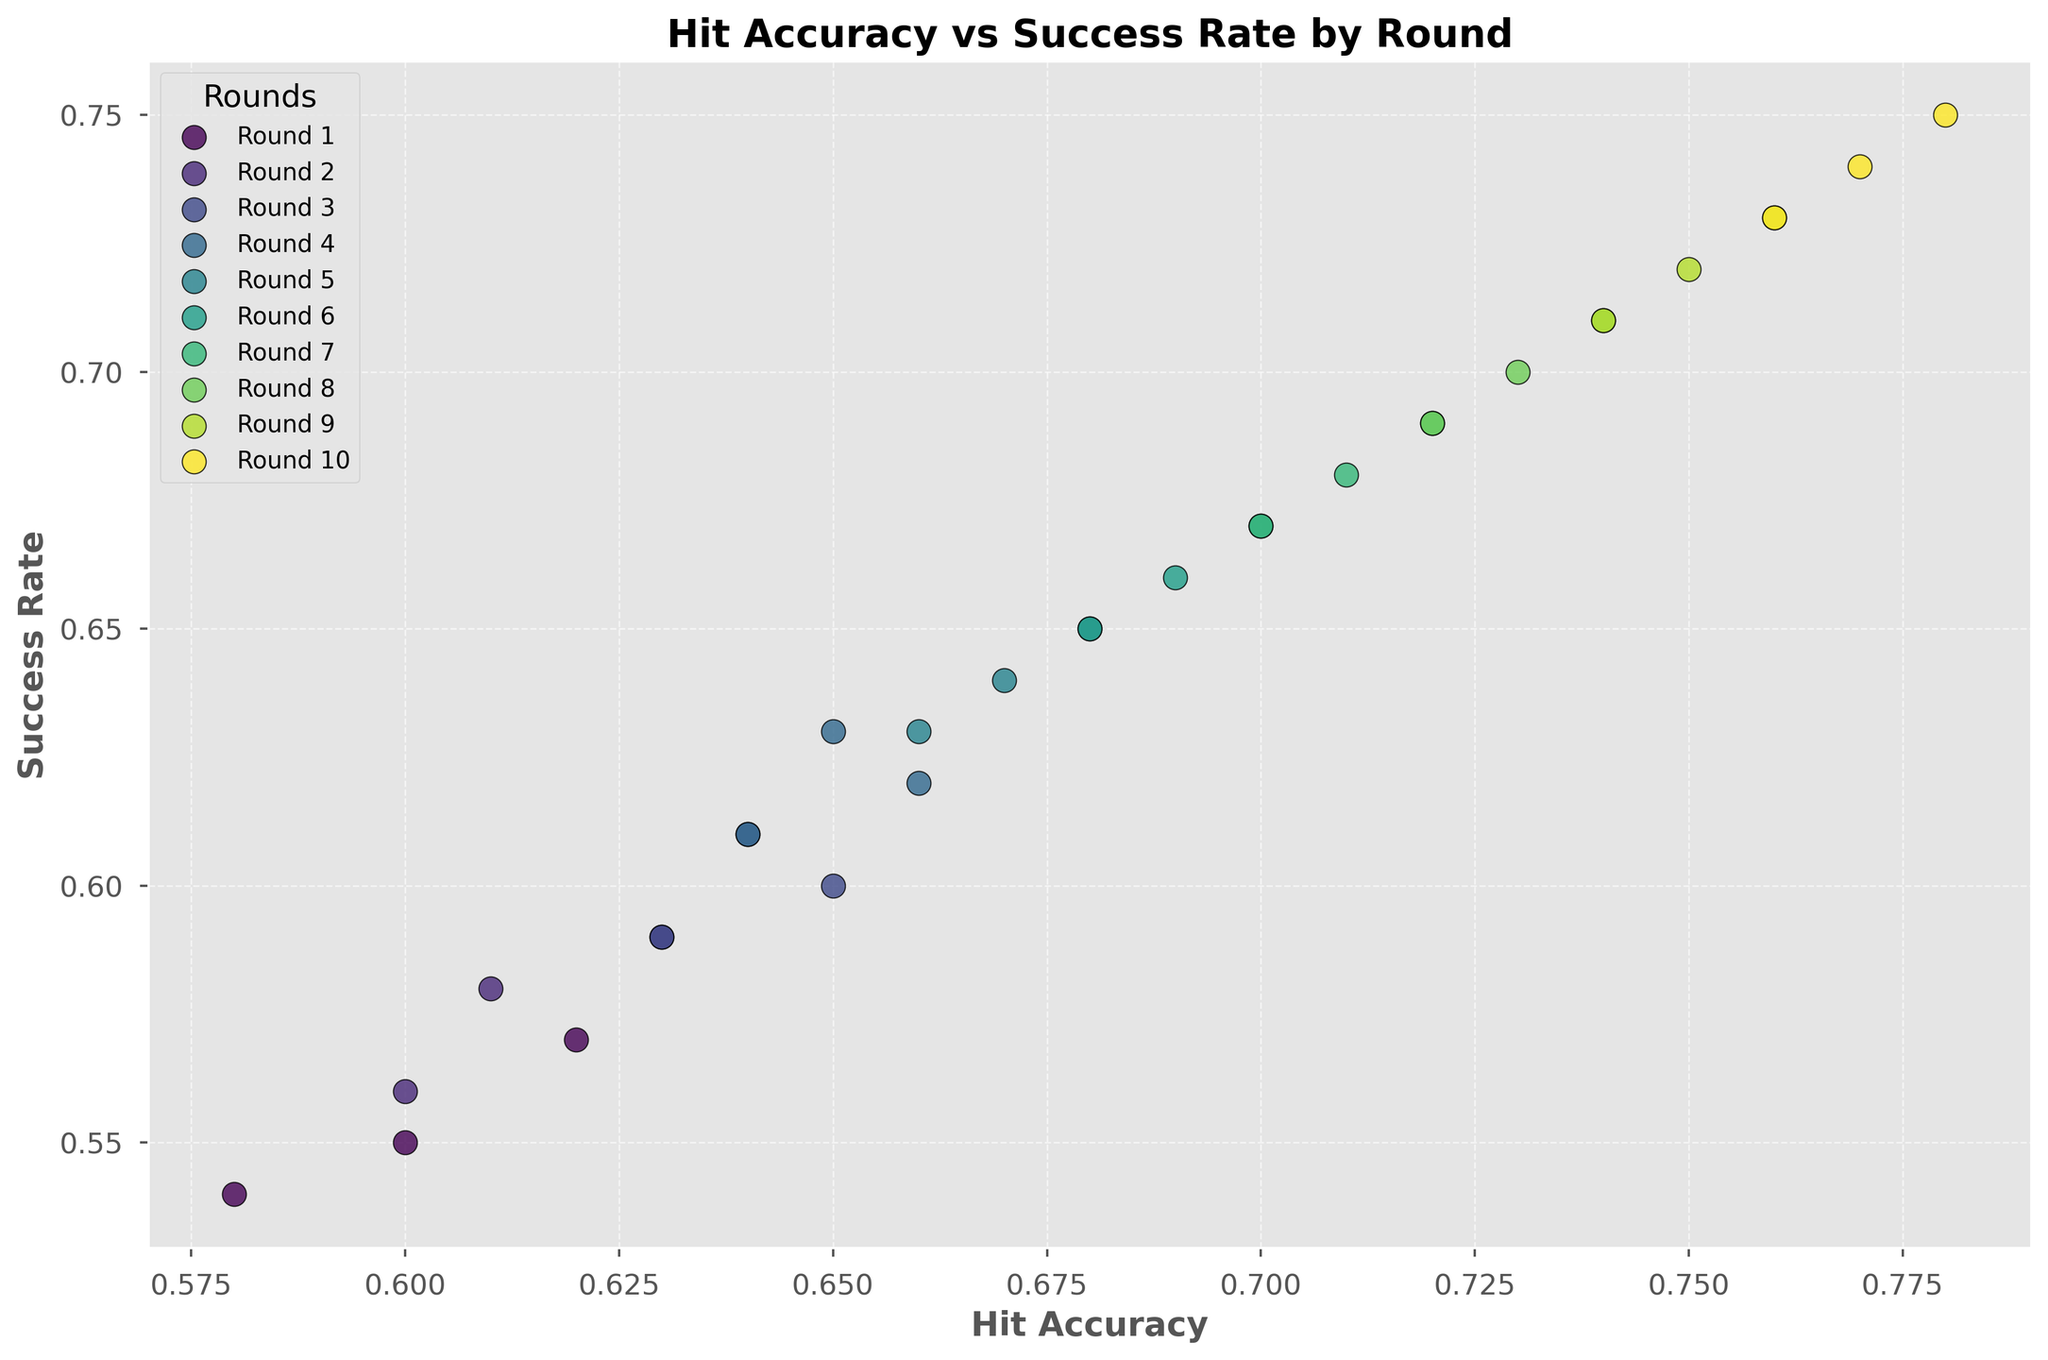What round shows the highest hit accuracy? By observing the scatter plot, look for the data points that are positioned furthest to the right (since hit accuracy is on the x-axis). The furthest right typically corresponds to the highest hit accuracy. In this case, it is the round with data points clustered around 0.78.
Answer: Round 10 Comparing rounds 1 and 5, which has a higher success rate? Locate the data points for rounds 1 and 5. Round 5 data points are centered around a success rate of 0.64-0.65, whereas round 1's data points are centered around 0.55-0.57. Therefore, round 5 has a clearly higher success rate.
Answer: Round 5 What is the average hit accuracy for rounds 4 and 6? Find the hit accuracy data points for rounds 4 and 6. For round 4; the points are 0.66, 0.65, and 0.64. For round 6; the points are 0.70, 0.69, and 0.68. Calculate the average for both rounds: 
((0.66+0.65+0.64)/3 + (0.70+0.69+0.68)/3)/2 = (0.65 + 0.69)/2 = 0.67
Answer: 0.67 Are the success rates for rounds 7 and 8 significantly different? Compare round 7's success rate (centered around 0.68-0.69) and round 8's success rate (centered around 0.70-0.71). The values are close but round 8 shows a marginally higher success rate.
Answer: No, they are not significantly different Which round shows a clear upward trend in both hit accuracy and success rate? Observe the rounds and see if there is an upward trend from lower left to upper right on both axes for a particular round cluster. Round 10 shows this trend clearly with high values in both metrics reaching 0.78 and 0.75.
Answer: Round 10 Which round has the least variation in hit accuracy? Look at the spread of the hit accuracy values for each round. For each round, note if the points are tightly clustered or spread out. Round 1, with hit accuracy values closely clustered around 0.60 to 0.62, has the least variation.
Answer: Round 1 Is there any round where the success rate exceeds 0.7? By observing the plot, look for any success rate data points higher than 0.7. Round 9 and 10 show success rates in the range of 0.73-0.75.
Answer: Yes, rounds 9 and 10 In which round do hit accuracy and success rate both show the closest values? Compare the gaps between the hit accuracy and the success rate in each round. Round 1 shows both hit accuracy (~0.60) and success rate (~0.55) values closest to each other.
Answer: Round 1 